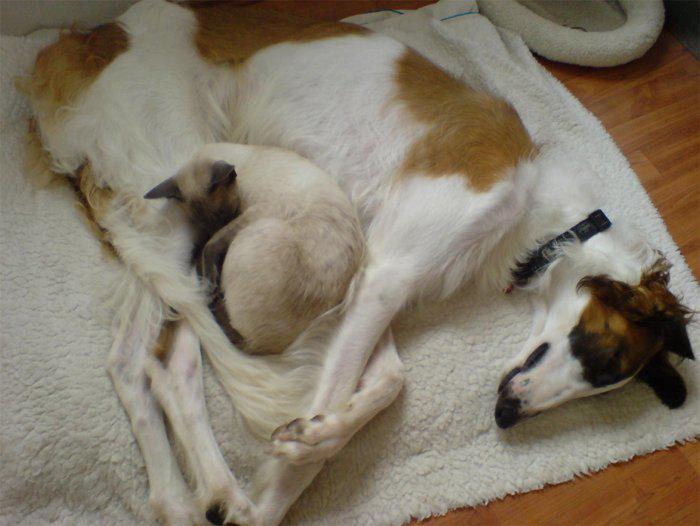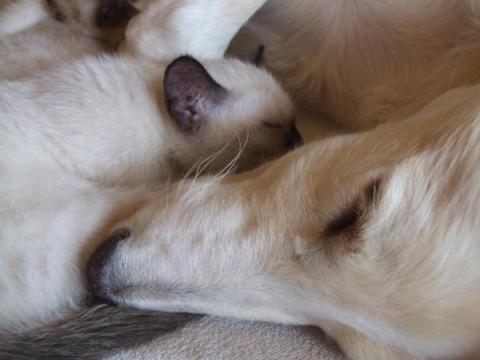The first image is the image on the left, the second image is the image on the right. Assess this claim about the two images: "There is exactly one sleeping dog wearing a collar.". Correct or not? Answer yes or no. Yes. 